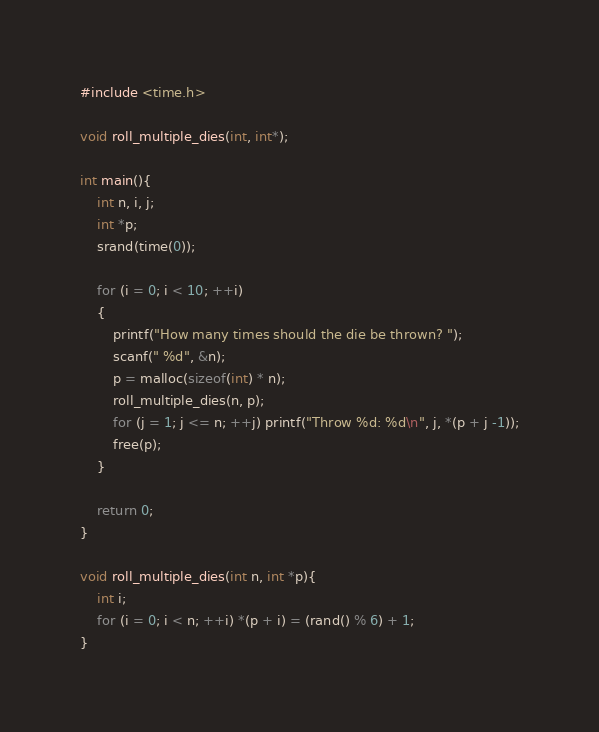Convert code to text. <code><loc_0><loc_0><loc_500><loc_500><_C_>#include <time.h>

void roll_multiple_dies(int, int*);

int main(){
	int n, i, j;
	int *p;
	srand(time(0));

	for (i = 0; i < 10; ++i)
	{
		printf("How many times should the die be thrown? ");
		scanf(" %d", &n);
		p = malloc(sizeof(int) * n);
		roll_multiple_dies(n, p);
		for (j = 1; j <= n; ++j) printf("Throw %d: %d\n", j, *(p + j -1));
		free(p);
	}

	return 0;
}

void roll_multiple_dies(int n, int *p){
	int i;
	for (i = 0; i < n; ++i) *(p + i) = (rand() % 6) + 1;
}</code> 